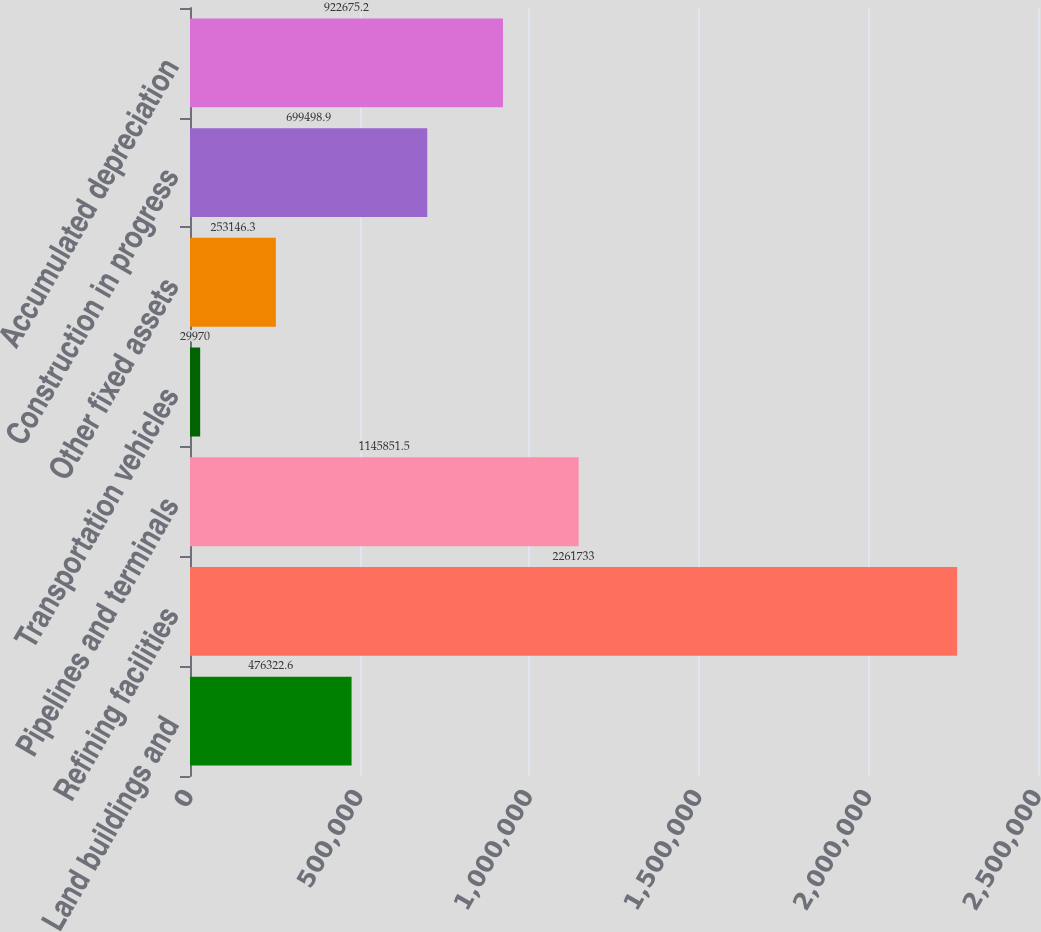Convert chart to OTSL. <chart><loc_0><loc_0><loc_500><loc_500><bar_chart><fcel>Land buildings and<fcel>Refining facilities<fcel>Pipelines and terminals<fcel>Transportation vehicles<fcel>Other fixed assets<fcel>Construction in progress<fcel>Accumulated depreciation<nl><fcel>476323<fcel>2.26173e+06<fcel>1.14585e+06<fcel>29970<fcel>253146<fcel>699499<fcel>922675<nl></chart> 